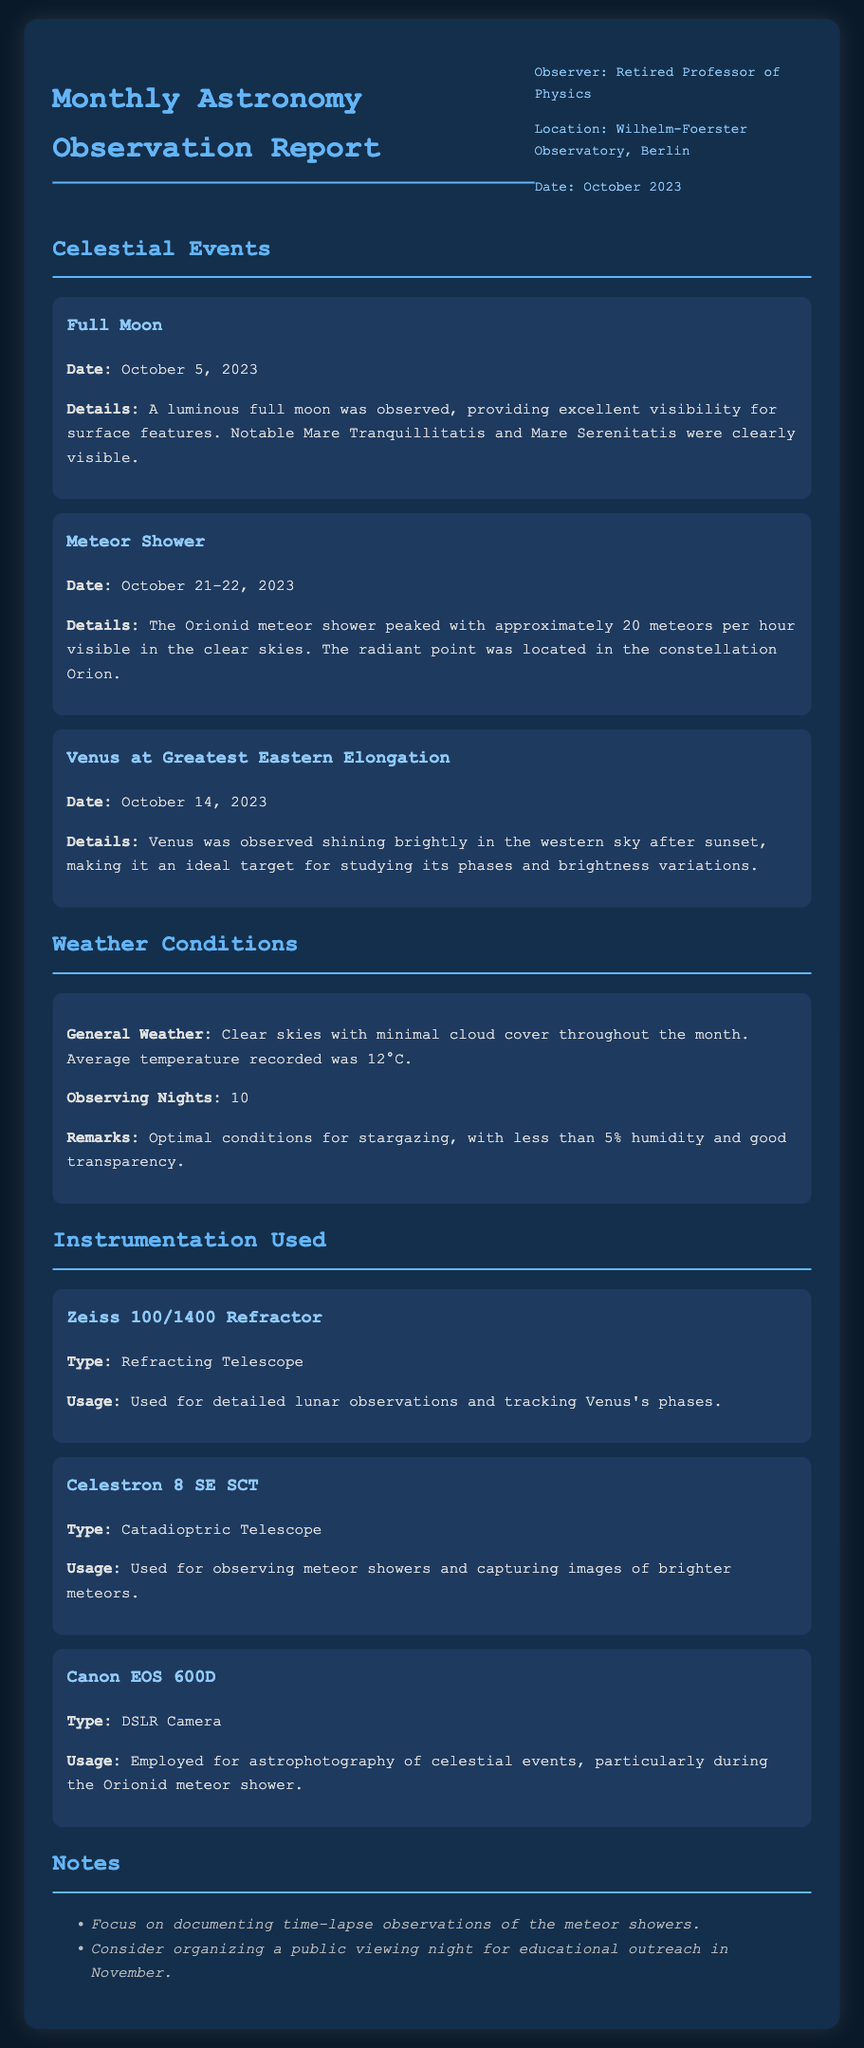What was the date of the Full Moon? The date of the Full Moon is specifically mentioned in the celestial events section of the document.
Answer: October 5, 2023 How many meteors per hour were visible during the Orionid meteor shower? This information is provided in the details of the meteor shower event observed during October 2023.
Answer: 20 What is the observing temperature recorded for October? The average temperature is stated in the weather conditions section of the document.
Answer: 12°C What telescope was used for observing Venus's phases? The instrument section lists which telescopes were utilized for specific observations, including Venus's phases.
Answer: Zeiss 100/1400 Refractor What type of weather was observed throughout the month? The general weather conditions are summarized in the weather section, describing the overall sky conditions.
Answer: Clear skies Why is Venus significant to observe on October 14, 2023? This reasoning involves understanding the details provided for that celestial event, explaining its visibility and brightness.
Answer: Ideal target for studying its phases and brightness variations How many observing nights were reported? The number of observing nights is specifically outlined in the weather conditions section of the report.
Answer: 10 What type of camera was used for astrophotography? This information is mentioned in the instrumentation section, specifically about the camera used for capturing celestial events.
Answer: Canon EOS 600D What event peaked on October 21-22, 2023? The document lists celestial events with specific dates, recognizing significant astronomical phenomena during this timeframe.
Answer: Meteor Shower 